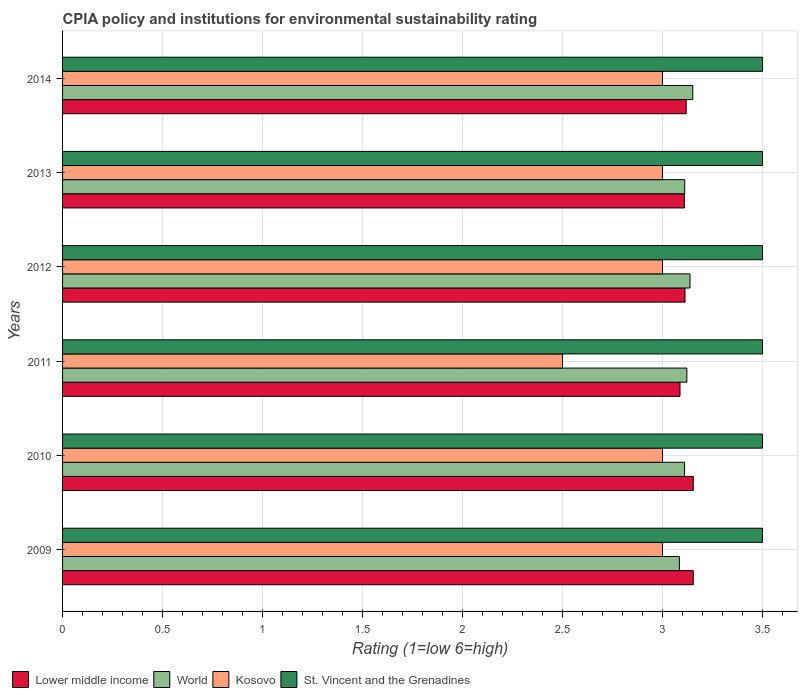Are the number of bars on each tick of the Y-axis equal?
Provide a short and direct response. Yes. What is the label of the 2nd group of bars from the top?
Provide a succinct answer. 2013. Across all years, what is the minimum CPIA rating in Kosovo?
Your response must be concise. 2.5. In which year was the CPIA rating in St. Vincent and the Grenadines minimum?
Offer a terse response. 2009. What is the total CPIA rating in Lower middle income in the graph?
Your response must be concise. 18.74. What is the difference between the CPIA rating in Lower middle income in 2010 and that in 2013?
Give a very brief answer. 0.04. What is the difference between the CPIA rating in St. Vincent and the Grenadines in 2009 and the CPIA rating in World in 2011?
Ensure brevity in your answer.  0.38. What is the average CPIA rating in St. Vincent and the Grenadines per year?
Make the answer very short. 3.5. In the year 2011, what is the difference between the CPIA rating in Lower middle income and CPIA rating in Kosovo?
Your answer should be very brief. 0.59. In how many years, is the CPIA rating in St. Vincent and the Grenadines greater than 2 ?
Provide a short and direct response. 6. What is the ratio of the CPIA rating in World in 2010 to that in 2012?
Your answer should be compact. 0.99. Is the CPIA rating in Kosovo in 2010 less than that in 2012?
Provide a succinct answer. No. Is the difference between the CPIA rating in Lower middle income in 2010 and 2014 greater than the difference between the CPIA rating in Kosovo in 2010 and 2014?
Your answer should be compact. Yes. What is the difference between the highest and the lowest CPIA rating in World?
Provide a short and direct response. 0.07. In how many years, is the CPIA rating in Kosovo greater than the average CPIA rating in Kosovo taken over all years?
Offer a terse response. 5. Is the sum of the CPIA rating in Kosovo in 2010 and 2011 greater than the maximum CPIA rating in World across all years?
Provide a succinct answer. Yes. What does the 1st bar from the top in 2009 represents?
Make the answer very short. St. Vincent and the Grenadines. What does the 4th bar from the bottom in 2012 represents?
Provide a short and direct response. St. Vincent and the Grenadines. Are all the bars in the graph horizontal?
Give a very brief answer. Yes. What is the difference between two consecutive major ticks on the X-axis?
Make the answer very short. 0.5. Are the values on the major ticks of X-axis written in scientific E-notation?
Provide a succinct answer. No. Does the graph contain any zero values?
Your answer should be compact. No. Where does the legend appear in the graph?
Your answer should be very brief. Bottom left. How are the legend labels stacked?
Give a very brief answer. Horizontal. What is the title of the graph?
Offer a very short reply. CPIA policy and institutions for environmental sustainability rating. What is the Rating (1=low 6=high) in Lower middle income in 2009?
Make the answer very short. 3.15. What is the Rating (1=low 6=high) in World in 2009?
Keep it short and to the point. 3.08. What is the Rating (1=low 6=high) in Kosovo in 2009?
Your answer should be very brief. 3. What is the Rating (1=low 6=high) of Lower middle income in 2010?
Ensure brevity in your answer.  3.15. What is the Rating (1=low 6=high) of World in 2010?
Your answer should be compact. 3.11. What is the Rating (1=low 6=high) in Kosovo in 2010?
Ensure brevity in your answer.  3. What is the Rating (1=low 6=high) of St. Vincent and the Grenadines in 2010?
Offer a terse response. 3.5. What is the Rating (1=low 6=high) of Lower middle income in 2011?
Provide a succinct answer. 3.09. What is the Rating (1=low 6=high) of World in 2011?
Your answer should be very brief. 3.12. What is the Rating (1=low 6=high) of Kosovo in 2011?
Offer a terse response. 2.5. What is the Rating (1=low 6=high) in St. Vincent and the Grenadines in 2011?
Offer a very short reply. 3.5. What is the Rating (1=low 6=high) of Lower middle income in 2012?
Give a very brief answer. 3.11. What is the Rating (1=low 6=high) in World in 2012?
Offer a very short reply. 3.14. What is the Rating (1=low 6=high) in St. Vincent and the Grenadines in 2012?
Your answer should be very brief. 3.5. What is the Rating (1=low 6=high) in Lower middle income in 2013?
Keep it short and to the point. 3.11. What is the Rating (1=low 6=high) in World in 2013?
Make the answer very short. 3.11. What is the Rating (1=low 6=high) of Lower middle income in 2014?
Ensure brevity in your answer.  3.12. What is the Rating (1=low 6=high) in World in 2014?
Provide a short and direct response. 3.15. What is the Rating (1=low 6=high) in St. Vincent and the Grenadines in 2014?
Give a very brief answer. 3.5. Across all years, what is the maximum Rating (1=low 6=high) of Lower middle income?
Keep it short and to the point. 3.15. Across all years, what is the maximum Rating (1=low 6=high) in World?
Give a very brief answer. 3.15. Across all years, what is the maximum Rating (1=low 6=high) of Kosovo?
Your answer should be very brief. 3. Across all years, what is the minimum Rating (1=low 6=high) in Lower middle income?
Your response must be concise. 3.09. Across all years, what is the minimum Rating (1=low 6=high) in World?
Your answer should be compact. 3.08. Across all years, what is the minimum Rating (1=low 6=high) of Kosovo?
Offer a terse response. 2.5. Across all years, what is the minimum Rating (1=low 6=high) in St. Vincent and the Grenadines?
Your answer should be compact. 3.5. What is the total Rating (1=low 6=high) of Lower middle income in the graph?
Offer a very short reply. 18.74. What is the total Rating (1=low 6=high) of World in the graph?
Your response must be concise. 18.72. What is the total Rating (1=low 6=high) of St. Vincent and the Grenadines in the graph?
Provide a short and direct response. 21. What is the difference between the Rating (1=low 6=high) of World in 2009 and that in 2010?
Provide a succinct answer. -0.03. What is the difference between the Rating (1=low 6=high) of St. Vincent and the Grenadines in 2009 and that in 2010?
Provide a succinct answer. 0. What is the difference between the Rating (1=low 6=high) in Lower middle income in 2009 and that in 2011?
Your response must be concise. 0.07. What is the difference between the Rating (1=low 6=high) of World in 2009 and that in 2011?
Keep it short and to the point. -0.04. What is the difference between the Rating (1=low 6=high) in Kosovo in 2009 and that in 2011?
Give a very brief answer. 0.5. What is the difference between the Rating (1=low 6=high) in St. Vincent and the Grenadines in 2009 and that in 2011?
Your answer should be compact. 0. What is the difference between the Rating (1=low 6=high) in Lower middle income in 2009 and that in 2012?
Keep it short and to the point. 0.04. What is the difference between the Rating (1=low 6=high) in World in 2009 and that in 2012?
Give a very brief answer. -0.05. What is the difference between the Rating (1=low 6=high) in Kosovo in 2009 and that in 2012?
Offer a terse response. 0. What is the difference between the Rating (1=low 6=high) of Lower middle income in 2009 and that in 2013?
Your answer should be very brief. 0.04. What is the difference between the Rating (1=low 6=high) of World in 2009 and that in 2013?
Provide a succinct answer. -0.03. What is the difference between the Rating (1=low 6=high) in Kosovo in 2009 and that in 2013?
Make the answer very short. 0. What is the difference between the Rating (1=low 6=high) in Lower middle income in 2009 and that in 2014?
Your answer should be very brief. 0.04. What is the difference between the Rating (1=low 6=high) of World in 2009 and that in 2014?
Ensure brevity in your answer.  -0.07. What is the difference between the Rating (1=low 6=high) of Kosovo in 2009 and that in 2014?
Keep it short and to the point. 0. What is the difference between the Rating (1=low 6=high) in Lower middle income in 2010 and that in 2011?
Keep it short and to the point. 0.07. What is the difference between the Rating (1=low 6=high) of World in 2010 and that in 2011?
Provide a succinct answer. -0.01. What is the difference between the Rating (1=low 6=high) of Kosovo in 2010 and that in 2011?
Give a very brief answer. 0.5. What is the difference between the Rating (1=low 6=high) of St. Vincent and the Grenadines in 2010 and that in 2011?
Your answer should be compact. 0. What is the difference between the Rating (1=low 6=high) in Lower middle income in 2010 and that in 2012?
Keep it short and to the point. 0.04. What is the difference between the Rating (1=low 6=high) in World in 2010 and that in 2012?
Your response must be concise. -0.03. What is the difference between the Rating (1=low 6=high) in Kosovo in 2010 and that in 2012?
Offer a very short reply. 0. What is the difference between the Rating (1=low 6=high) in Lower middle income in 2010 and that in 2013?
Keep it short and to the point. 0.04. What is the difference between the Rating (1=low 6=high) of World in 2010 and that in 2013?
Ensure brevity in your answer.  -0. What is the difference between the Rating (1=low 6=high) of Kosovo in 2010 and that in 2013?
Give a very brief answer. 0. What is the difference between the Rating (1=low 6=high) in St. Vincent and the Grenadines in 2010 and that in 2013?
Keep it short and to the point. 0. What is the difference between the Rating (1=low 6=high) of Lower middle income in 2010 and that in 2014?
Ensure brevity in your answer.  0.04. What is the difference between the Rating (1=low 6=high) of World in 2010 and that in 2014?
Offer a terse response. -0.04. What is the difference between the Rating (1=low 6=high) of Kosovo in 2010 and that in 2014?
Provide a short and direct response. 0. What is the difference between the Rating (1=low 6=high) in Lower middle income in 2011 and that in 2012?
Make the answer very short. -0.03. What is the difference between the Rating (1=low 6=high) in World in 2011 and that in 2012?
Ensure brevity in your answer.  -0.02. What is the difference between the Rating (1=low 6=high) of St. Vincent and the Grenadines in 2011 and that in 2012?
Ensure brevity in your answer.  0. What is the difference between the Rating (1=low 6=high) of Lower middle income in 2011 and that in 2013?
Offer a terse response. -0.02. What is the difference between the Rating (1=low 6=high) of World in 2011 and that in 2013?
Your answer should be very brief. 0.01. What is the difference between the Rating (1=low 6=high) of Lower middle income in 2011 and that in 2014?
Your response must be concise. -0.03. What is the difference between the Rating (1=low 6=high) of World in 2011 and that in 2014?
Your response must be concise. -0.03. What is the difference between the Rating (1=low 6=high) of Kosovo in 2011 and that in 2014?
Provide a succinct answer. -0.5. What is the difference between the Rating (1=low 6=high) of Lower middle income in 2012 and that in 2013?
Give a very brief answer. 0. What is the difference between the Rating (1=low 6=high) of World in 2012 and that in 2013?
Offer a very short reply. 0.03. What is the difference between the Rating (1=low 6=high) of Kosovo in 2012 and that in 2013?
Offer a very short reply. 0. What is the difference between the Rating (1=low 6=high) of Lower middle income in 2012 and that in 2014?
Keep it short and to the point. -0.01. What is the difference between the Rating (1=low 6=high) of World in 2012 and that in 2014?
Provide a succinct answer. -0.01. What is the difference between the Rating (1=low 6=high) of St. Vincent and the Grenadines in 2012 and that in 2014?
Your answer should be very brief. 0. What is the difference between the Rating (1=low 6=high) in Lower middle income in 2013 and that in 2014?
Offer a very short reply. -0.01. What is the difference between the Rating (1=low 6=high) of World in 2013 and that in 2014?
Provide a short and direct response. -0.04. What is the difference between the Rating (1=low 6=high) of St. Vincent and the Grenadines in 2013 and that in 2014?
Offer a terse response. 0. What is the difference between the Rating (1=low 6=high) of Lower middle income in 2009 and the Rating (1=low 6=high) of World in 2010?
Make the answer very short. 0.04. What is the difference between the Rating (1=low 6=high) in Lower middle income in 2009 and the Rating (1=low 6=high) in Kosovo in 2010?
Provide a short and direct response. 0.15. What is the difference between the Rating (1=low 6=high) in Lower middle income in 2009 and the Rating (1=low 6=high) in St. Vincent and the Grenadines in 2010?
Give a very brief answer. -0.35. What is the difference between the Rating (1=low 6=high) in World in 2009 and the Rating (1=low 6=high) in Kosovo in 2010?
Ensure brevity in your answer.  0.08. What is the difference between the Rating (1=low 6=high) of World in 2009 and the Rating (1=low 6=high) of St. Vincent and the Grenadines in 2010?
Give a very brief answer. -0.42. What is the difference between the Rating (1=low 6=high) of Kosovo in 2009 and the Rating (1=low 6=high) of St. Vincent and the Grenadines in 2010?
Give a very brief answer. -0.5. What is the difference between the Rating (1=low 6=high) in Lower middle income in 2009 and the Rating (1=low 6=high) in World in 2011?
Your answer should be very brief. 0.03. What is the difference between the Rating (1=low 6=high) of Lower middle income in 2009 and the Rating (1=low 6=high) of Kosovo in 2011?
Give a very brief answer. 0.65. What is the difference between the Rating (1=low 6=high) in Lower middle income in 2009 and the Rating (1=low 6=high) in St. Vincent and the Grenadines in 2011?
Provide a succinct answer. -0.35. What is the difference between the Rating (1=low 6=high) in World in 2009 and the Rating (1=low 6=high) in Kosovo in 2011?
Offer a very short reply. 0.58. What is the difference between the Rating (1=low 6=high) of World in 2009 and the Rating (1=low 6=high) of St. Vincent and the Grenadines in 2011?
Your answer should be compact. -0.42. What is the difference between the Rating (1=low 6=high) in Lower middle income in 2009 and the Rating (1=low 6=high) in World in 2012?
Make the answer very short. 0.02. What is the difference between the Rating (1=low 6=high) of Lower middle income in 2009 and the Rating (1=low 6=high) of Kosovo in 2012?
Offer a terse response. 0.15. What is the difference between the Rating (1=low 6=high) of Lower middle income in 2009 and the Rating (1=low 6=high) of St. Vincent and the Grenadines in 2012?
Ensure brevity in your answer.  -0.35. What is the difference between the Rating (1=low 6=high) in World in 2009 and the Rating (1=low 6=high) in Kosovo in 2012?
Offer a terse response. 0.08. What is the difference between the Rating (1=low 6=high) in World in 2009 and the Rating (1=low 6=high) in St. Vincent and the Grenadines in 2012?
Keep it short and to the point. -0.42. What is the difference between the Rating (1=low 6=high) of Kosovo in 2009 and the Rating (1=low 6=high) of St. Vincent and the Grenadines in 2012?
Give a very brief answer. -0.5. What is the difference between the Rating (1=low 6=high) in Lower middle income in 2009 and the Rating (1=low 6=high) in World in 2013?
Your answer should be compact. 0.04. What is the difference between the Rating (1=low 6=high) in Lower middle income in 2009 and the Rating (1=low 6=high) in Kosovo in 2013?
Ensure brevity in your answer.  0.15. What is the difference between the Rating (1=low 6=high) of Lower middle income in 2009 and the Rating (1=low 6=high) of St. Vincent and the Grenadines in 2013?
Provide a short and direct response. -0.35. What is the difference between the Rating (1=low 6=high) of World in 2009 and the Rating (1=low 6=high) of Kosovo in 2013?
Give a very brief answer. 0.08. What is the difference between the Rating (1=low 6=high) of World in 2009 and the Rating (1=low 6=high) of St. Vincent and the Grenadines in 2013?
Provide a short and direct response. -0.42. What is the difference between the Rating (1=low 6=high) of Kosovo in 2009 and the Rating (1=low 6=high) of St. Vincent and the Grenadines in 2013?
Give a very brief answer. -0.5. What is the difference between the Rating (1=low 6=high) of Lower middle income in 2009 and the Rating (1=low 6=high) of World in 2014?
Make the answer very short. 0. What is the difference between the Rating (1=low 6=high) in Lower middle income in 2009 and the Rating (1=low 6=high) in Kosovo in 2014?
Make the answer very short. 0.15. What is the difference between the Rating (1=low 6=high) of Lower middle income in 2009 and the Rating (1=low 6=high) of St. Vincent and the Grenadines in 2014?
Your response must be concise. -0.35. What is the difference between the Rating (1=low 6=high) in World in 2009 and the Rating (1=low 6=high) in Kosovo in 2014?
Offer a terse response. 0.08. What is the difference between the Rating (1=low 6=high) of World in 2009 and the Rating (1=low 6=high) of St. Vincent and the Grenadines in 2014?
Offer a very short reply. -0.42. What is the difference between the Rating (1=low 6=high) in Kosovo in 2009 and the Rating (1=low 6=high) in St. Vincent and the Grenadines in 2014?
Your answer should be very brief. -0.5. What is the difference between the Rating (1=low 6=high) of Lower middle income in 2010 and the Rating (1=low 6=high) of World in 2011?
Make the answer very short. 0.03. What is the difference between the Rating (1=low 6=high) of Lower middle income in 2010 and the Rating (1=low 6=high) of Kosovo in 2011?
Your answer should be very brief. 0.65. What is the difference between the Rating (1=low 6=high) in Lower middle income in 2010 and the Rating (1=low 6=high) in St. Vincent and the Grenadines in 2011?
Your answer should be very brief. -0.35. What is the difference between the Rating (1=low 6=high) of World in 2010 and the Rating (1=low 6=high) of Kosovo in 2011?
Your answer should be very brief. 0.61. What is the difference between the Rating (1=low 6=high) of World in 2010 and the Rating (1=low 6=high) of St. Vincent and the Grenadines in 2011?
Your answer should be very brief. -0.39. What is the difference between the Rating (1=low 6=high) in Kosovo in 2010 and the Rating (1=low 6=high) in St. Vincent and the Grenadines in 2011?
Offer a terse response. -0.5. What is the difference between the Rating (1=low 6=high) in Lower middle income in 2010 and the Rating (1=low 6=high) in World in 2012?
Your answer should be very brief. 0.02. What is the difference between the Rating (1=low 6=high) of Lower middle income in 2010 and the Rating (1=low 6=high) of Kosovo in 2012?
Provide a succinct answer. 0.15. What is the difference between the Rating (1=low 6=high) in Lower middle income in 2010 and the Rating (1=low 6=high) in St. Vincent and the Grenadines in 2012?
Provide a short and direct response. -0.35. What is the difference between the Rating (1=low 6=high) in World in 2010 and the Rating (1=low 6=high) in Kosovo in 2012?
Your response must be concise. 0.11. What is the difference between the Rating (1=low 6=high) in World in 2010 and the Rating (1=low 6=high) in St. Vincent and the Grenadines in 2012?
Your response must be concise. -0.39. What is the difference between the Rating (1=low 6=high) in Kosovo in 2010 and the Rating (1=low 6=high) in St. Vincent and the Grenadines in 2012?
Your answer should be compact. -0.5. What is the difference between the Rating (1=low 6=high) of Lower middle income in 2010 and the Rating (1=low 6=high) of World in 2013?
Provide a short and direct response. 0.04. What is the difference between the Rating (1=low 6=high) of Lower middle income in 2010 and the Rating (1=low 6=high) of Kosovo in 2013?
Provide a succinct answer. 0.15. What is the difference between the Rating (1=low 6=high) of Lower middle income in 2010 and the Rating (1=low 6=high) of St. Vincent and the Grenadines in 2013?
Your answer should be compact. -0.35. What is the difference between the Rating (1=low 6=high) of World in 2010 and the Rating (1=low 6=high) of Kosovo in 2013?
Provide a short and direct response. 0.11. What is the difference between the Rating (1=low 6=high) of World in 2010 and the Rating (1=low 6=high) of St. Vincent and the Grenadines in 2013?
Your response must be concise. -0.39. What is the difference between the Rating (1=low 6=high) in Kosovo in 2010 and the Rating (1=low 6=high) in St. Vincent and the Grenadines in 2013?
Give a very brief answer. -0.5. What is the difference between the Rating (1=low 6=high) in Lower middle income in 2010 and the Rating (1=low 6=high) in World in 2014?
Provide a short and direct response. 0. What is the difference between the Rating (1=low 6=high) of Lower middle income in 2010 and the Rating (1=low 6=high) of Kosovo in 2014?
Your answer should be very brief. 0.15. What is the difference between the Rating (1=low 6=high) of Lower middle income in 2010 and the Rating (1=low 6=high) of St. Vincent and the Grenadines in 2014?
Ensure brevity in your answer.  -0.35. What is the difference between the Rating (1=low 6=high) of World in 2010 and the Rating (1=low 6=high) of Kosovo in 2014?
Give a very brief answer. 0.11. What is the difference between the Rating (1=low 6=high) of World in 2010 and the Rating (1=low 6=high) of St. Vincent and the Grenadines in 2014?
Offer a terse response. -0.39. What is the difference between the Rating (1=low 6=high) in Kosovo in 2010 and the Rating (1=low 6=high) in St. Vincent and the Grenadines in 2014?
Provide a short and direct response. -0.5. What is the difference between the Rating (1=low 6=high) in Lower middle income in 2011 and the Rating (1=low 6=high) in Kosovo in 2012?
Your response must be concise. 0.09. What is the difference between the Rating (1=low 6=high) of Lower middle income in 2011 and the Rating (1=low 6=high) of St. Vincent and the Grenadines in 2012?
Your answer should be compact. -0.41. What is the difference between the Rating (1=low 6=high) in World in 2011 and the Rating (1=low 6=high) in Kosovo in 2012?
Give a very brief answer. 0.12. What is the difference between the Rating (1=low 6=high) in World in 2011 and the Rating (1=low 6=high) in St. Vincent and the Grenadines in 2012?
Make the answer very short. -0.38. What is the difference between the Rating (1=low 6=high) of Kosovo in 2011 and the Rating (1=low 6=high) of St. Vincent and the Grenadines in 2012?
Your answer should be compact. -1. What is the difference between the Rating (1=low 6=high) in Lower middle income in 2011 and the Rating (1=low 6=high) in World in 2013?
Provide a short and direct response. -0.02. What is the difference between the Rating (1=low 6=high) of Lower middle income in 2011 and the Rating (1=low 6=high) of Kosovo in 2013?
Your answer should be compact. 0.09. What is the difference between the Rating (1=low 6=high) of Lower middle income in 2011 and the Rating (1=low 6=high) of St. Vincent and the Grenadines in 2013?
Provide a short and direct response. -0.41. What is the difference between the Rating (1=low 6=high) in World in 2011 and the Rating (1=low 6=high) in Kosovo in 2013?
Offer a very short reply. 0.12. What is the difference between the Rating (1=low 6=high) of World in 2011 and the Rating (1=low 6=high) of St. Vincent and the Grenadines in 2013?
Your response must be concise. -0.38. What is the difference between the Rating (1=low 6=high) in Lower middle income in 2011 and the Rating (1=low 6=high) in World in 2014?
Your answer should be very brief. -0.06. What is the difference between the Rating (1=low 6=high) of Lower middle income in 2011 and the Rating (1=low 6=high) of Kosovo in 2014?
Provide a short and direct response. 0.09. What is the difference between the Rating (1=low 6=high) of Lower middle income in 2011 and the Rating (1=low 6=high) of St. Vincent and the Grenadines in 2014?
Your answer should be very brief. -0.41. What is the difference between the Rating (1=low 6=high) in World in 2011 and the Rating (1=low 6=high) in Kosovo in 2014?
Offer a very short reply. 0.12. What is the difference between the Rating (1=low 6=high) in World in 2011 and the Rating (1=low 6=high) in St. Vincent and the Grenadines in 2014?
Ensure brevity in your answer.  -0.38. What is the difference between the Rating (1=low 6=high) in Kosovo in 2011 and the Rating (1=low 6=high) in St. Vincent and the Grenadines in 2014?
Provide a succinct answer. -1. What is the difference between the Rating (1=low 6=high) in Lower middle income in 2012 and the Rating (1=low 6=high) in World in 2013?
Provide a short and direct response. 0. What is the difference between the Rating (1=low 6=high) of Lower middle income in 2012 and the Rating (1=low 6=high) of Kosovo in 2013?
Provide a succinct answer. 0.11. What is the difference between the Rating (1=low 6=high) of Lower middle income in 2012 and the Rating (1=low 6=high) of St. Vincent and the Grenadines in 2013?
Offer a terse response. -0.39. What is the difference between the Rating (1=low 6=high) in World in 2012 and the Rating (1=low 6=high) in Kosovo in 2013?
Your answer should be compact. 0.14. What is the difference between the Rating (1=low 6=high) in World in 2012 and the Rating (1=low 6=high) in St. Vincent and the Grenadines in 2013?
Ensure brevity in your answer.  -0.36. What is the difference between the Rating (1=low 6=high) in Lower middle income in 2012 and the Rating (1=low 6=high) in World in 2014?
Make the answer very short. -0.04. What is the difference between the Rating (1=low 6=high) in Lower middle income in 2012 and the Rating (1=low 6=high) in Kosovo in 2014?
Your answer should be very brief. 0.11. What is the difference between the Rating (1=low 6=high) of Lower middle income in 2012 and the Rating (1=low 6=high) of St. Vincent and the Grenadines in 2014?
Give a very brief answer. -0.39. What is the difference between the Rating (1=low 6=high) of World in 2012 and the Rating (1=low 6=high) of Kosovo in 2014?
Provide a short and direct response. 0.14. What is the difference between the Rating (1=low 6=high) in World in 2012 and the Rating (1=low 6=high) in St. Vincent and the Grenadines in 2014?
Your answer should be compact. -0.36. What is the difference between the Rating (1=low 6=high) in Kosovo in 2012 and the Rating (1=low 6=high) in St. Vincent and the Grenadines in 2014?
Offer a terse response. -0.5. What is the difference between the Rating (1=low 6=high) in Lower middle income in 2013 and the Rating (1=low 6=high) in World in 2014?
Keep it short and to the point. -0.04. What is the difference between the Rating (1=low 6=high) in Lower middle income in 2013 and the Rating (1=low 6=high) in Kosovo in 2014?
Your answer should be compact. 0.11. What is the difference between the Rating (1=low 6=high) of Lower middle income in 2013 and the Rating (1=low 6=high) of St. Vincent and the Grenadines in 2014?
Keep it short and to the point. -0.39. What is the difference between the Rating (1=low 6=high) of World in 2013 and the Rating (1=low 6=high) of Kosovo in 2014?
Offer a terse response. 0.11. What is the difference between the Rating (1=low 6=high) of World in 2013 and the Rating (1=low 6=high) of St. Vincent and the Grenadines in 2014?
Give a very brief answer. -0.39. What is the difference between the Rating (1=low 6=high) of Kosovo in 2013 and the Rating (1=low 6=high) of St. Vincent and the Grenadines in 2014?
Provide a short and direct response. -0.5. What is the average Rating (1=low 6=high) of Lower middle income per year?
Offer a very short reply. 3.12. What is the average Rating (1=low 6=high) of World per year?
Make the answer very short. 3.12. What is the average Rating (1=low 6=high) in Kosovo per year?
Offer a terse response. 2.92. In the year 2009, what is the difference between the Rating (1=low 6=high) in Lower middle income and Rating (1=low 6=high) in World?
Offer a terse response. 0.07. In the year 2009, what is the difference between the Rating (1=low 6=high) of Lower middle income and Rating (1=low 6=high) of Kosovo?
Give a very brief answer. 0.15. In the year 2009, what is the difference between the Rating (1=low 6=high) of Lower middle income and Rating (1=low 6=high) of St. Vincent and the Grenadines?
Your response must be concise. -0.35. In the year 2009, what is the difference between the Rating (1=low 6=high) of World and Rating (1=low 6=high) of Kosovo?
Your answer should be very brief. 0.08. In the year 2009, what is the difference between the Rating (1=low 6=high) of World and Rating (1=low 6=high) of St. Vincent and the Grenadines?
Keep it short and to the point. -0.42. In the year 2009, what is the difference between the Rating (1=low 6=high) in Kosovo and Rating (1=low 6=high) in St. Vincent and the Grenadines?
Offer a very short reply. -0.5. In the year 2010, what is the difference between the Rating (1=low 6=high) of Lower middle income and Rating (1=low 6=high) of World?
Ensure brevity in your answer.  0.04. In the year 2010, what is the difference between the Rating (1=low 6=high) of Lower middle income and Rating (1=low 6=high) of Kosovo?
Make the answer very short. 0.15. In the year 2010, what is the difference between the Rating (1=low 6=high) of Lower middle income and Rating (1=low 6=high) of St. Vincent and the Grenadines?
Make the answer very short. -0.35. In the year 2010, what is the difference between the Rating (1=low 6=high) of World and Rating (1=low 6=high) of Kosovo?
Your answer should be compact. 0.11. In the year 2010, what is the difference between the Rating (1=low 6=high) of World and Rating (1=low 6=high) of St. Vincent and the Grenadines?
Your response must be concise. -0.39. In the year 2011, what is the difference between the Rating (1=low 6=high) of Lower middle income and Rating (1=low 6=high) of World?
Provide a short and direct response. -0.03. In the year 2011, what is the difference between the Rating (1=low 6=high) in Lower middle income and Rating (1=low 6=high) in Kosovo?
Keep it short and to the point. 0.59. In the year 2011, what is the difference between the Rating (1=low 6=high) in Lower middle income and Rating (1=low 6=high) in St. Vincent and the Grenadines?
Make the answer very short. -0.41. In the year 2011, what is the difference between the Rating (1=low 6=high) in World and Rating (1=low 6=high) in Kosovo?
Offer a very short reply. 0.62. In the year 2011, what is the difference between the Rating (1=low 6=high) in World and Rating (1=low 6=high) in St. Vincent and the Grenadines?
Provide a short and direct response. -0.38. In the year 2012, what is the difference between the Rating (1=low 6=high) of Lower middle income and Rating (1=low 6=high) of World?
Keep it short and to the point. -0.03. In the year 2012, what is the difference between the Rating (1=low 6=high) in Lower middle income and Rating (1=low 6=high) in Kosovo?
Your answer should be compact. 0.11. In the year 2012, what is the difference between the Rating (1=low 6=high) in Lower middle income and Rating (1=low 6=high) in St. Vincent and the Grenadines?
Provide a short and direct response. -0.39. In the year 2012, what is the difference between the Rating (1=low 6=high) of World and Rating (1=low 6=high) of Kosovo?
Your response must be concise. 0.14. In the year 2012, what is the difference between the Rating (1=low 6=high) in World and Rating (1=low 6=high) in St. Vincent and the Grenadines?
Ensure brevity in your answer.  -0.36. In the year 2012, what is the difference between the Rating (1=low 6=high) in Kosovo and Rating (1=low 6=high) in St. Vincent and the Grenadines?
Make the answer very short. -0.5. In the year 2013, what is the difference between the Rating (1=low 6=high) in Lower middle income and Rating (1=low 6=high) in World?
Provide a short and direct response. -0. In the year 2013, what is the difference between the Rating (1=low 6=high) of Lower middle income and Rating (1=low 6=high) of Kosovo?
Provide a succinct answer. 0.11. In the year 2013, what is the difference between the Rating (1=low 6=high) in Lower middle income and Rating (1=low 6=high) in St. Vincent and the Grenadines?
Keep it short and to the point. -0.39. In the year 2013, what is the difference between the Rating (1=low 6=high) of World and Rating (1=low 6=high) of St. Vincent and the Grenadines?
Provide a succinct answer. -0.39. In the year 2014, what is the difference between the Rating (1=low 6=high) of Lower middle income and Rating (1=low 6=high) of World?
Keep it short and to the point. -0.03. In the year 2014, what is the difference between the Rating (1=low 6=high) in Lower middle income and Rating (1=low 6=high) in Kosovo?
Provide a succinct answer. 0.12. In the year 2014, what is the difference between the Rating (1=low 6=high) in Lower middle income and Rating (1=low 6=high) in St. Vincent and the Grenadines?
Provide a succinct answer. -0.38. In the year 2014, what is the difference between the Rating (1=low 6=high) in World and Rating (1=low 6=high) in Kosovo?
Your response must be concise. 0.15. In the year 2014, what is the difference between the Rating (1=low 6=high) of World and Rating (1=low 6=high) of St. Vincent and the Grenadines?
Offer a very short reply. -0.35. In the year 2014, what is the difference between the Rating (1=low 6=high) in Kosovo and Rating (1=low 6=high) in St. Vincent and the Grenadines?
Ensure brevity in your answer.  -0.5. What is the ratio of the Rating (1=low 6=high) of World in 2009 to that in 2010?
Ensure brevity in your answer.  0.99. What is the ratio of the Rating (1=low 6=high) in Kosovo in 2009 to that in 2010?
Provide a succinct answer. 1. What is the ratio of the Rating (1=low 6=high) in St. Vincent and the Grenadines in 2009 to that in 2010?
Keep it short and to the point. 1. What is the ratio of the Rating (1=low 6=high) in Lower middle income in 2009 to that in 2011?
Give a very brief answer. 1.02. What is the ratio of the Rating (1=low 6=high) in World in 2009 to that in 2011?
Offer a terse response. 0.99. What is the ratio of the Rating (1=low 6=high) in Kosovo in 2009 to that in 2011?
Your answer should be very brief. 1.2. What is the ratio of the Rating (1=low 6=high) of Lower middle income in 2009 to that in 2012?
Give a very brief answer. 1.01. What is the ratio of the Rating (1=low 6=high) of World in 2009 to that in 2012?
Make the answer very short. 0.98. What is the ratio of the Rating (1=low 6=high) in Kosovo in 2009 to that in 2012?
Your answer should be compact. 1. What is the ratio of the Rating (1=low 6=high) in St. Vincent and the Grenadines in 2009 to that in 2012?
Offer a very short reply. 1. What is the ratio of the Rating (1=low 6=high) of Lower middle income in 2009 to that in 2013?
Your response must be concise. 1.01. What is the ratio of the Rating (1=low 6=high) of Kosovo in 2009 to that in 2013?
Offer a very short reply. 1. What is the ratio of the Rating (1=low 6=high) of Lower middle income in 2009 to that in 2014?
Provide a succinct answer. 1.01. What is the ratio of the Rating (1=low 6=high) of World in 2009 to that in 2014?
Make the answer very short. 0.98. What is the ratio of the Rating (1=low 6=high) of Kosovo in 2009 to that in 2014?
Your answer should be very brief. 1. What is the ratio of the Rating (1=low 6=high) of St. Vincent and the Grenadines in 2009 to that in 2014?
Make the answer very short. 1. What is the ratio of the Rating (1=low 6=high) of Lower middle income in 2010 to that in 2011?
Give a very brief answer. 1.02. What is the ratio of the Rating (1=low 6=high) of Kosovo in 2010 to that in 2011?
Offer a terse response. 1.2. What is the ratio of the Rating (1=low 6=high) of Lower middle income in 2010 to that in 2012?
Offer a terse response. 1.01. What is the ratio of the Rating (1=low 6=high) of Lower middle income in 2010 to that in 2013?
Offer a very short reply. 1.01. What is the ratio of the Rating (1=low 6=high) of Kosovo in 2010 to that in 2013?
Your answer should be compact. 1. What is the ratio of the Rating (1=low 6=high) of Lower middle income in 2010 to that in 2014?
Keep it short and to the point. 1.01. What is the ratio of the Rating (1=low 6=high) of World in 2010 to that in 2014?
Make the answer very short. 0.99. What is the ratio of the Rating (1=low 6=high) in St. Vincent and the Grenadines in 2010 to that in 2014?
Your answer should be compact. 1. What is the ratio of the Rating (1=low 6=high) in Kosovo in 2011 to that in 2013?
Offer a very short reply. 0.83. What is the ratio of the Rating (1=low 6=high) in St. Vincent and the Grenadines in 2011 to that in 2013?
Offer a terse response. 1. What is the ratio of the Rating (1=low 6=high) of World in 2011 to that in 2014?
Provide a succinct answer. 0.99. What is the ratio of the Rating (1=low 6=high) of Kosovo in 2011 to that in 2014?
Provide a succinct answer. 0.83. What is the ratio of the Rating (1=low 6=high) of St. Vincent and the Grenadines in 2011 to that in 2014?
Your answer should be compact. 1. What is the ratio of the Rating (1=low 6=high) of World in 2012 to that in 2013?
Ensure brevity in your answer.  1.01. What is the ratio of the Rating (1=low 6=high) in World in 2012 to that in 2014?
Give a very brief answer. 1. What is the ratio of the Rating (1=low 6=high) of Kosovo in 2012 to that in 2014?
Make the answer very short. 1. What is the ratio of the Rating (1=low 6=high) in World in 2013 to that in 2014?
Make the answer very short. 0.99. What is the ratio of the Rating (1=low 6=high) in Kosovo in 2013 to that in 2014?
Keep it short and to the point. 1. What is the difference between the highest and the second highest Rating (1=low 6=high) in World?
Your answer should be very brief. 0.01. What is the difference between the highest and the second highest Rating (1=low 6=high) in Kosovo?
Give a very brief answer. 0. What is the difference between the highest and the second highest Rating (1=low 6=high) in St. Vincent and the Grenadines?
Offer a very short reply. 0. What is the difference between the highest and the lowest Rating (1=low 6=high) of Lower middle income?
Provide a succinct answer. 0.07. What is the difference between the highest and the lowest Rating (1=low 6=high) in World?
Offer a very short reply. 0.07. What is the difference between the highest and the lowest Rating (1=low 6=high) in Kosovo?
Your answer should be compact. 0.5. What is the difference between the highest and the lowest Rating (1=low 6=high) of St. Vincent and the Grenadines?
Your answer should be compact. 0. 